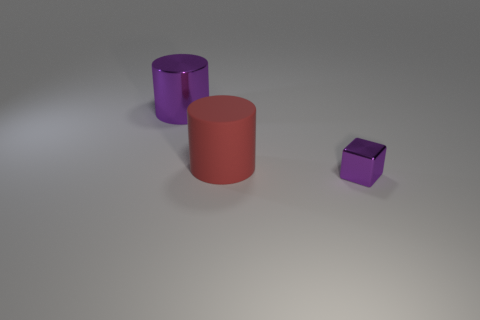Are there any other things that have the same material as the red cylinder?
Make the answer very short. No. Do the large metallic cylinder and the tiny metal cube have the same color?
Make the answer very short. Yes. There is a purple object on the left side of the purple metal object in front of the object left of the big red rubber cylinder; what is its material?
Offer a very short reply. Metal. Is there a brown matte cylinder that has the same size as the red rubber thing?
Your answer should be compact. No. There is a big matte object; what shape is it?
Your answer should be compact. Cylinder. What number of cylinders are purple metallic objects or large purple metal objects?
Provide a succinct answer. 1. Are there an equal number of cylinders right of the tiny purple block and big purple cylinders that are behind the large purple metallic cylinder?
Offer a terse response. Yes. There is a big object that is behind the red cylinder behind the small purple metallic thing; what number of red matte things are left of it?
Your answer should be very brief. 0. What shape is the big metal thing that is the same color as the small object?
Make the answer very short. Cylinder. There is a tiny thing; does it have the same color as the shiny thing behind the tiny purple cube?
Provide a succinct answer. Yes. 